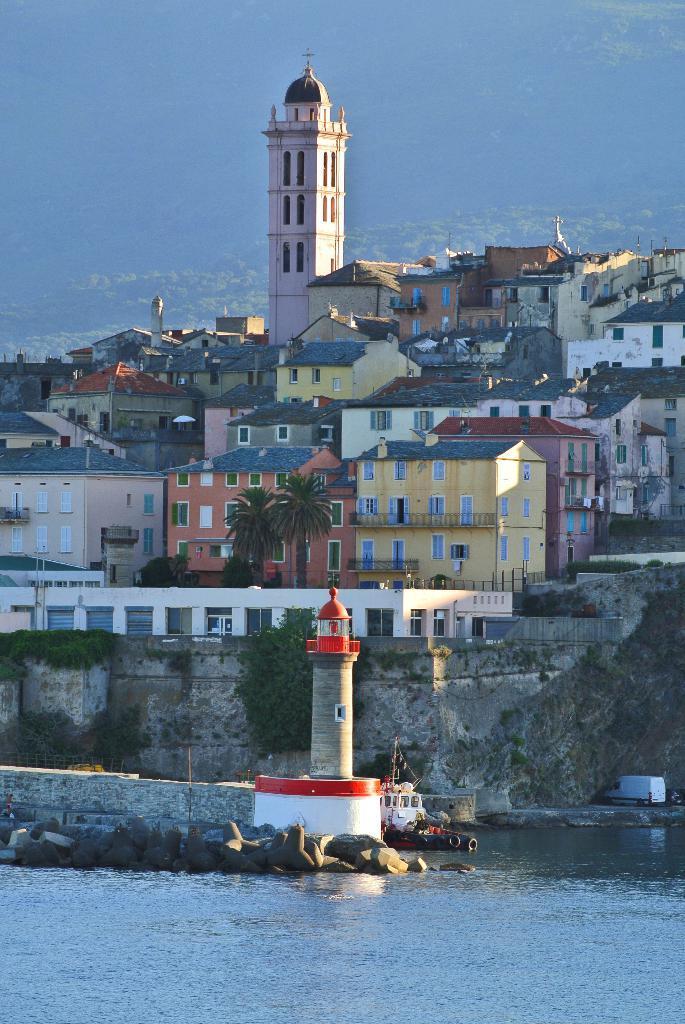Describe this image in one or two sentences. In this image we can see a lighthouse, the rocks and a ship in a water body. We can also see a group of houses, buildings, trees, plants, poles and a car beside the fence. On the right side of the image we can see a van placed on the surface. 